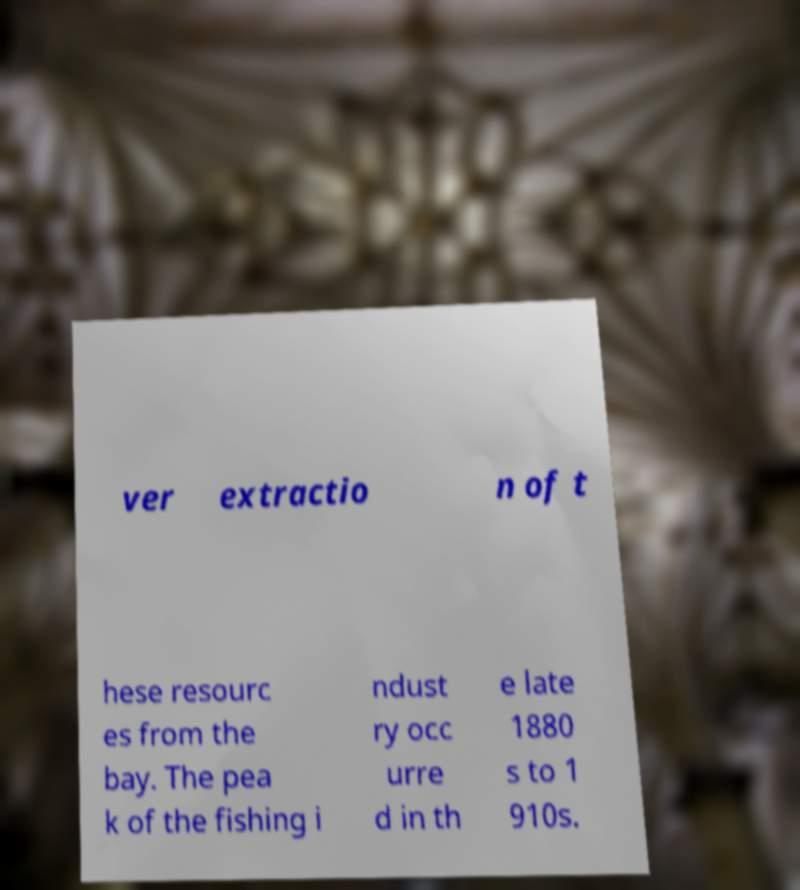There's text embedded in this image that I need extracted. Can you transcribe it verbatim? ver extractio n of t hese resourc es from the bay. The pea k of the fishing i ndust ry occ urre d in th e late 1880 s to 1 910s. 